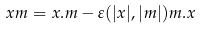Convert formula to latex. <formula><loc_0><loc_0><loc_500><loc_500>x m = x . m - \varepsilon ( | x | , | m | ) m . x</formula> 